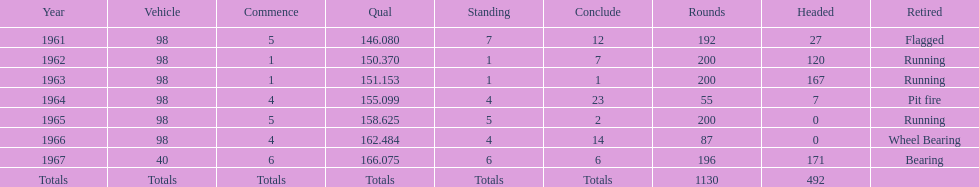What is the difference between the qualfying time in 1967 and 1965? 7.45. 